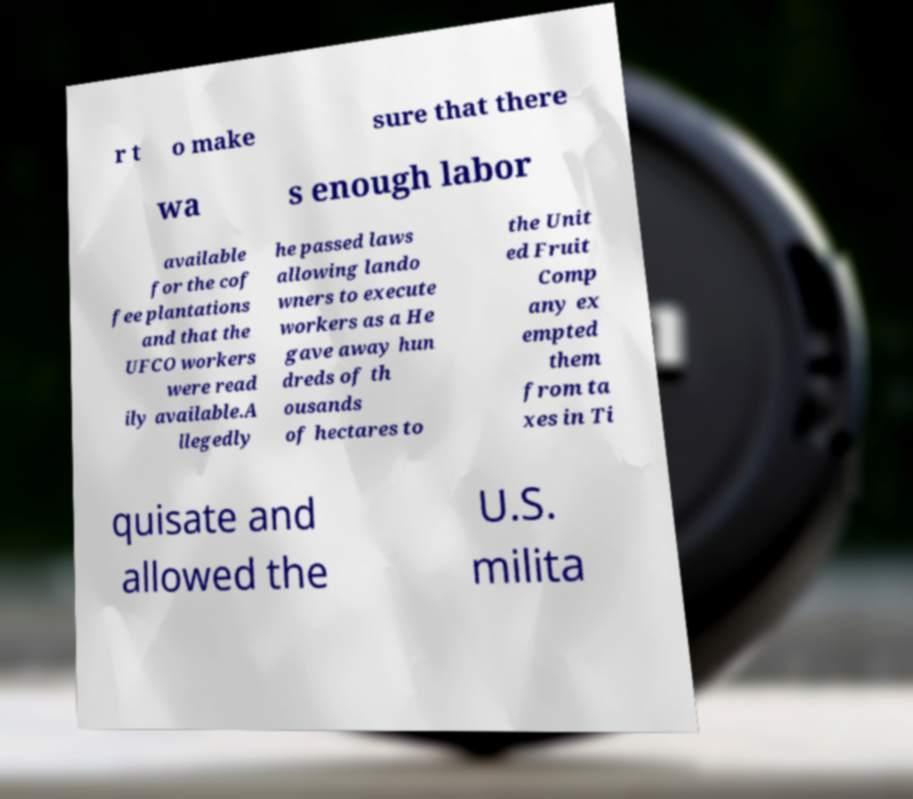Please identify and transcribe the text found in this image. r t o make sure that there wa s enough labor available for the cof fee plantations and that the UFCO workers were read ily available.A llegedly he passed laws allowing lando wners to execute workers as a He gave away hun dreds of th ousands of hectares to the Unit ed Fruit Comp any ex empted them from ta xes in Ti quisate and allowed the U.S. milita 